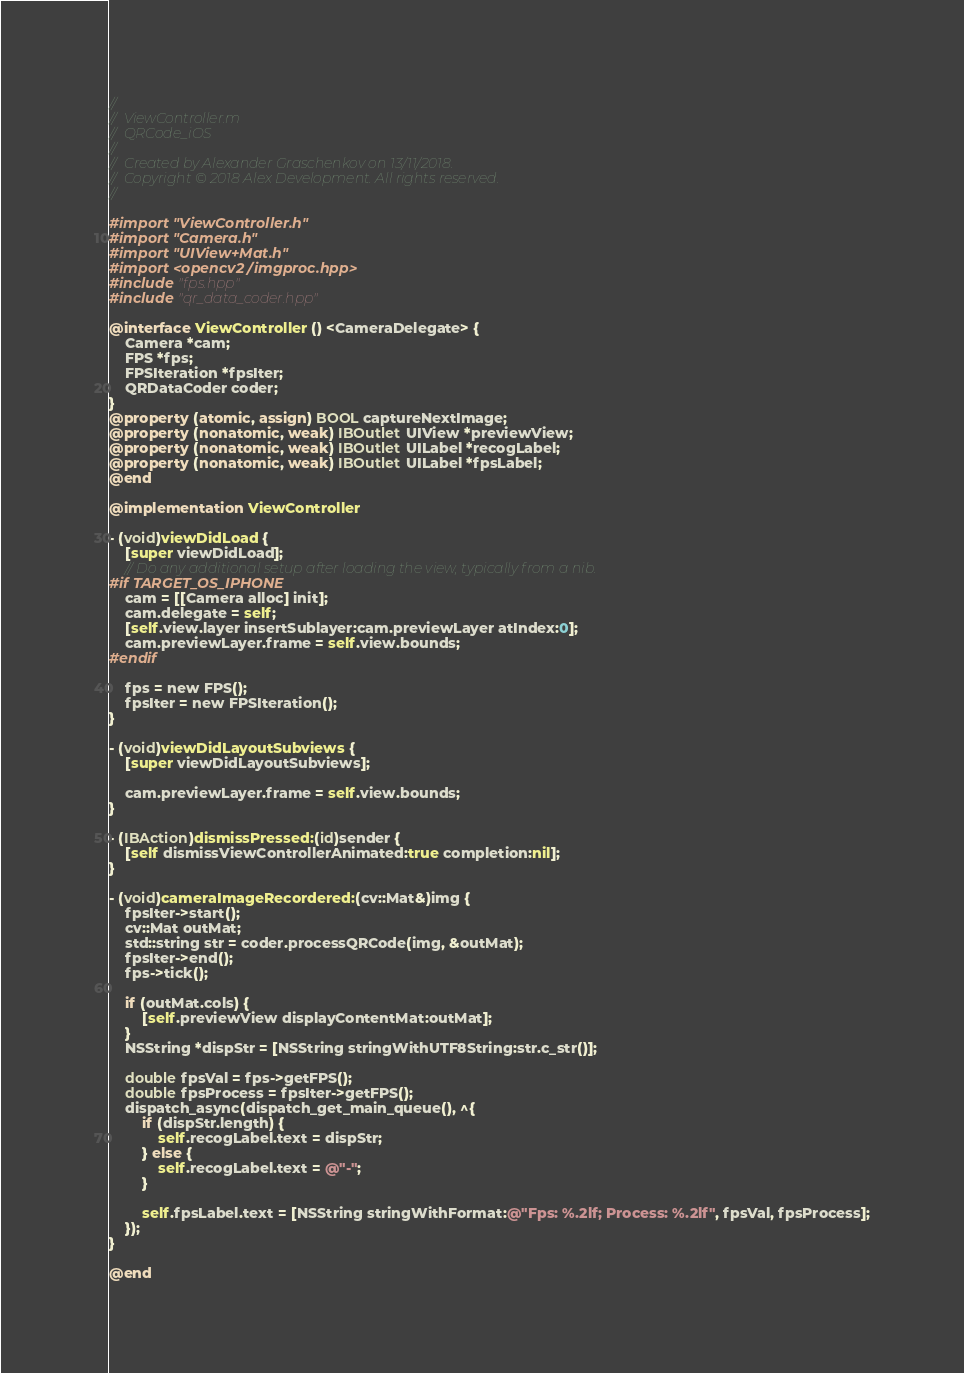<code> <loc_0><loc_0><loc_500><loc_500><_ObjectiveC_>//
//  ViewController.m
//  QRCode_iOS
//
//  Created by Alexander Graschenkov on 13/11/2018.
//  Copyright © 2018 Alex Development. All rights reserved.
//

#import "ViewController.h"
#import "Camera.h"
#import "UIView+Mat.h"
#import <opencv2/imgproc.hpp>
#include "fps.hpp"
#include "qr_data_coder.hpp"

@interface ViewController () <CameraDelegate> {
    Camera *cam;
    FPS *fps;
    FPSIteration *fpsIter;
    QRDataCoder coder;
}
@property (atomic, assign) BOOL captureNextImage;
@property (nonatomic, weak) IBOutlet UIView *previewView;
@property (nonatomic, weak) IBOutlet UILabel *recogLabel;
@property (nonatomic, weak) IBOutlet UILabel *fpsLabel;
@end

@implementation ViewController

- (void)viewDidLoad {
    [super viewDidLoad];
    // Do any additional setup after loading the view, typically from a nib.
#if TARGET_OS_IPHONE
    cam = [[Camera alloc] init];
    cam.delegate = self;
    [self.view.layer insertSublayer:cam.previewLayer atIndex:0];
    cam.previewLayer.frame = self.view.bounds;
#endif
    
    fps = new FPS();
    fpsIter = new FPSIteration();
}

- (void)viewDidLayoutSubviews {
    [super viewDidLayoutSubviews];
    
    cam.previewLayer.frame = self.view.bounds;
}

- (IBAction)dismissPressed:(id)sender {
    [self dismissViewControllerAnimated:true completion:nil];
}

- (void)cameraImageRecordered:(cv::Mat&)img {
    fpsIter->start();
    cv::Mat outMat;
    std::string str = coder.processQRCode(img, &outMat);
    fpsIter->end();
    fps->tick();
    
    if (outMat.cols) {
        [self.previewView displayContentMat:outMat];
    }
    NSString *dispStr = [NSString stringWithUTF8String:str.c_str()];
    
    double fpsVal = fps->getFPS();
    double fpsProcess = fpsIter->getFPS();
    dispatch_async(dispatch_get_main_queue(), ^{
        if (dispStr.length) {
            self.recogLabel.text = dispStr;
        } else {
            self.recogLabel.text = @"-";
        }
        
        self.fpsLabel.text = [NSString stringWithFormat:@"Fps: %.2lf; Process: %.2lf", fpsVal, fpsProcess];
    });
}

@end
</code> 